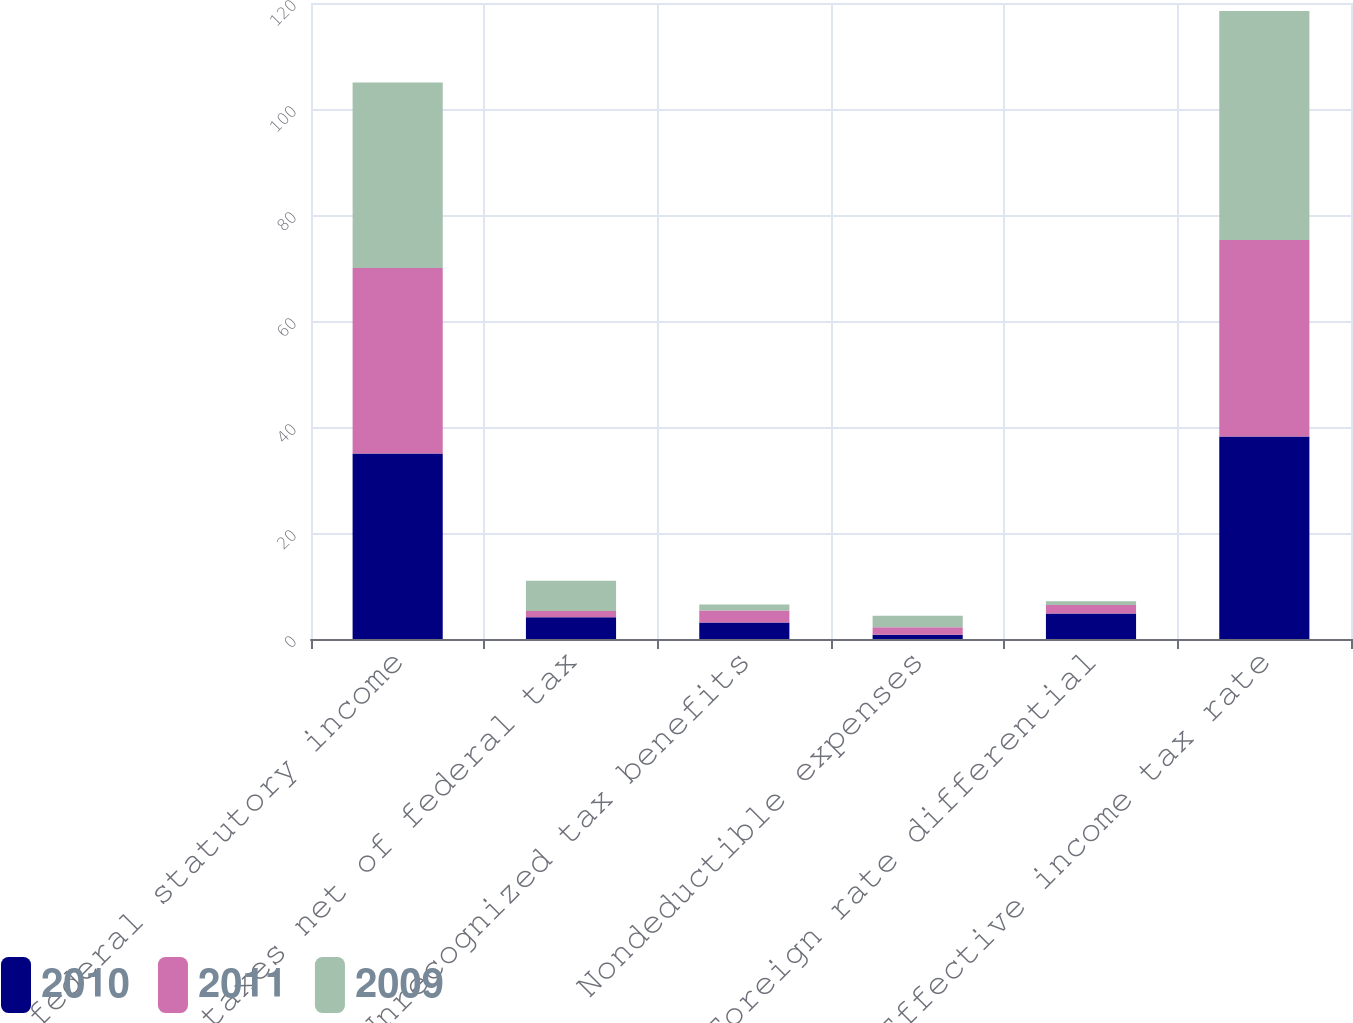<chart> <loc_0><loc_0><loc_500><loc_500><stacked_bar_chart><ecel><fcel>US federal statutory income<fcel>State taxes net of federal tax<fcel>Unrecognized tax benefits<fcel>Nondeductible expenses<fcel>Foreign rate differential<fcel>Effective income tax rate<nl><fcel>2010<fcel>35<fcel>4.1<fcel>3.1<fcel>0.8<fcel>4.8<fcel>38.2<nl><fcel>2011<fcel>35<fcel>1.2<fcel>2.3<fcel>1.4<fcel>1.6<fcel>37.1<nl><fcel>2009<fcel>35<fcel>5.7<fcel>1.1<fcel>2.2<fcel>0.7<fcel>43.2<nl></chart> 